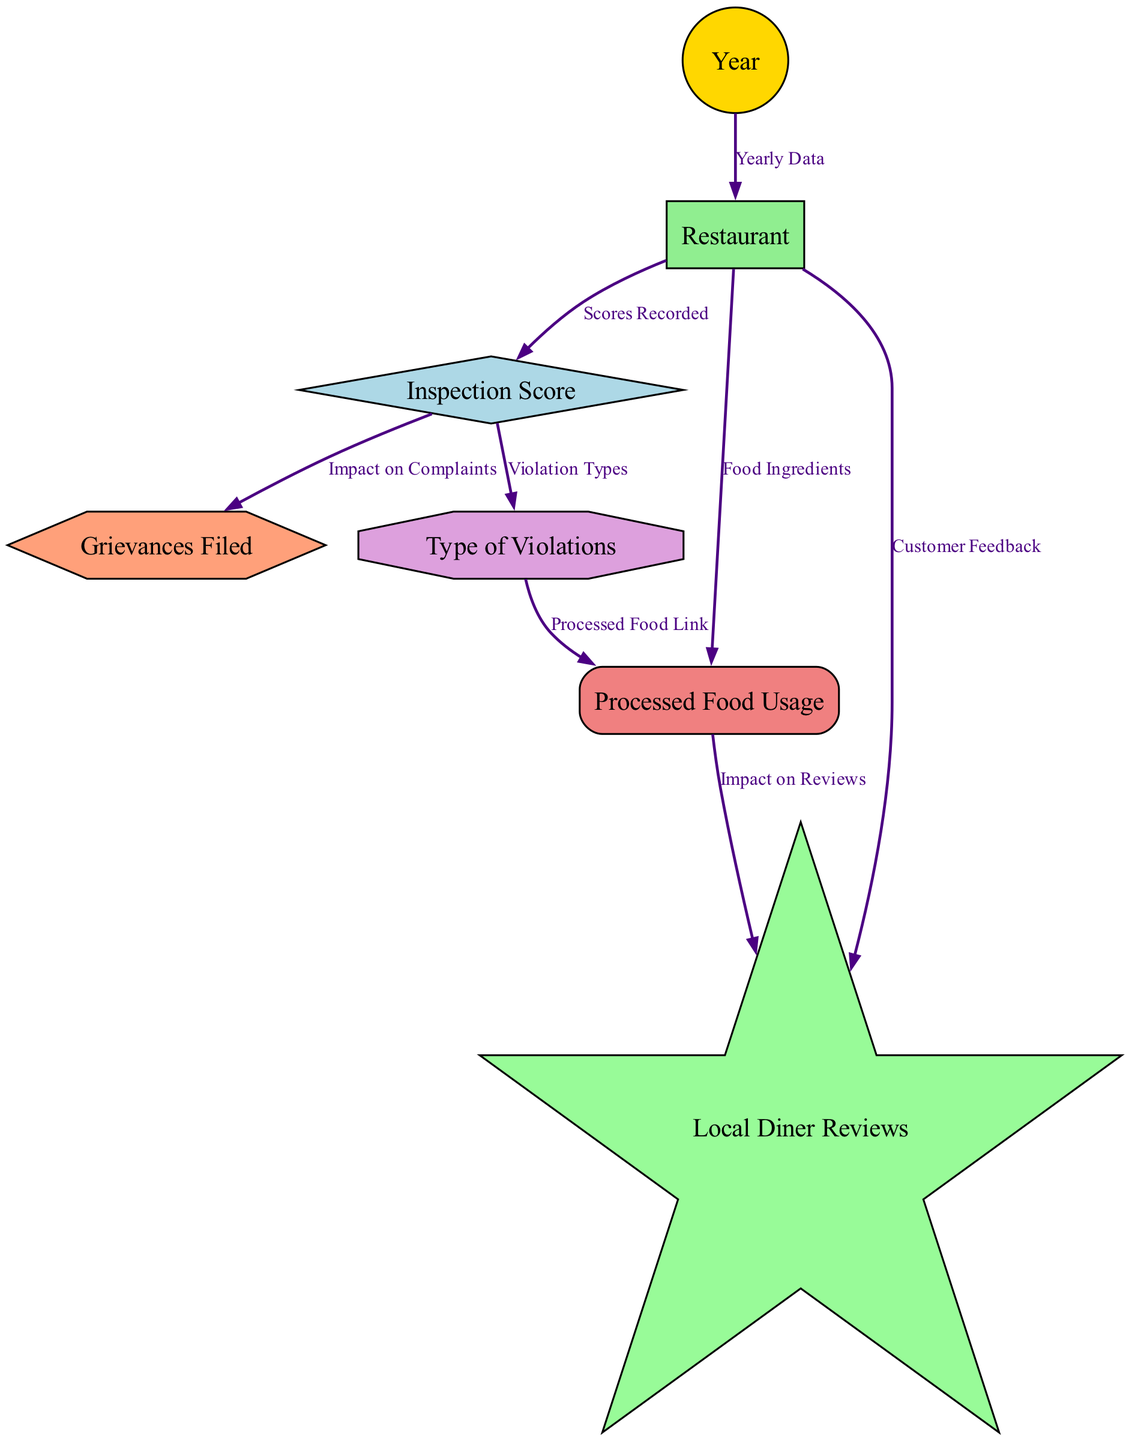What is the connection between "Year" and "Restaurant"? The connection is labeled "Yearly Data," indicating that the data for each restaurant is recorded annually. This shows how inspections relate to the year of data collection.
Answer: Yearly Data How many nodes are present in the diagram? The diagram includes a total of 7 nodes, each representing a distinct aspect related to food safety inspection such as Year, Restaurant, Inspection Score, etc.
Answer: 7 What type of shape represents "Inspection Score"? The Inspection Score is represented by a diamond shape in the diagram, which is distinct from other shapes used for different nodes.
Answer: Diamond Which node is influenced by "Processed Food Usage"? The "Local Diner Reviews" node is influenced by "Processed Food Usage" as indicated by the directed edge connecting these two nodes. This suggests that the type of food used can impact customer feedback.
Answer: Local Diner Reviews What is the primary impact of "Inspection Score" as per the diagram? The primary impact of the Inspection Score is on "Grievances Filed," suggesting that higher scores correlate with fewer complaints. This relationship indicates the direct effect of food safety evaluations on customer feedback and legal actions.
Answer: Impact on Complaints What is the relationship between "Type of Violations" and "Processed Food Usage"? The relationship is labeled "Processed Food Link," indicating that the kind of violations observed during inspections is connected to the usage of processed foods, revealing potential areas of concern in food safety.
Answer: Processed Food Link How does "Restaurant" relate to "Customer Feedback"? "Restaurant" is directly related to "Customer Feedback," denoting that each restaurant's performance influences the reviews it receives from diners, forming a feedback loop.
Answer: Customer Feedback What is indicated by the edge labeled "Scores Recorded"? The edge labeled "Scores Recorded" connects the "Restaurant" and "Inspection Score" nodes. This implies that inspection scores are documented for each restaurant, establishing a record of compliance and safety standards over time.
Answer: Scores Recorded What represents the type of violations in the diagram? The type of violations in the diagram is represented by the octagon shape associated with the "Type of Violations" node, highlighting its distinction from other categories.
Answer: Octagon 